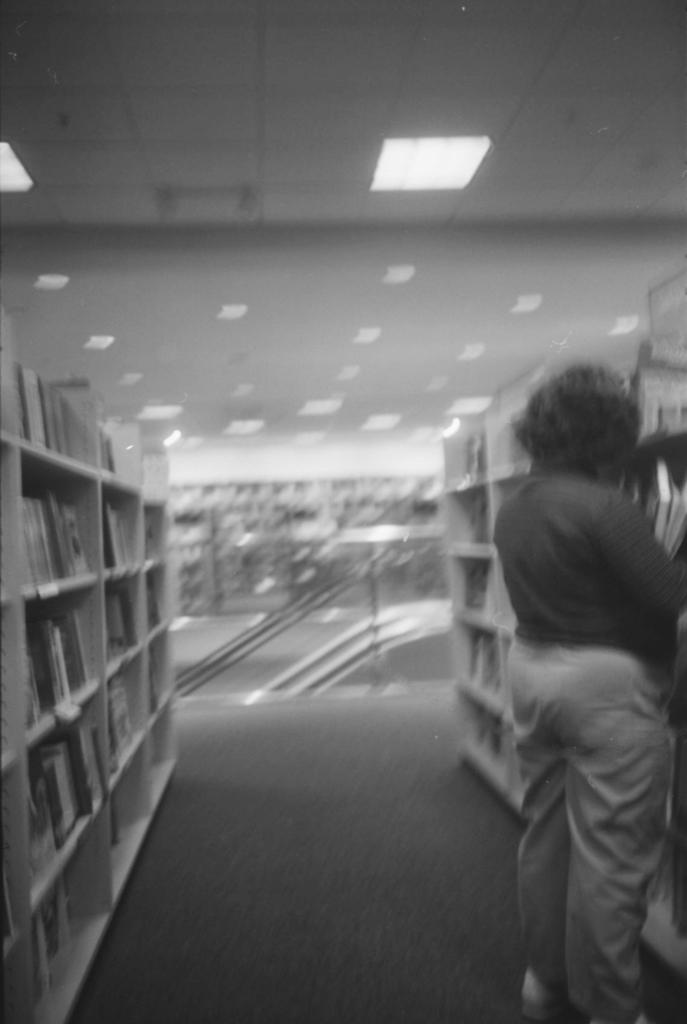What is the color scheme of the image? The image is black and white. Where is the picture taken? It is an inside picture of a library. What can be seen in the image besides the library setting? There is a person standing in front of a bookshelf. What type of lighting is present in the image? There are fall ceiling lights at the top of the roof. What verse does the person recite in the image? There is no indication in the image that the person is reciting a verse. 